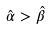Convert formula to latex. <formula><loc_0><loc_0><loc_500><loc_500>\hat { \alpha } > \hat { \beta }</formula> 